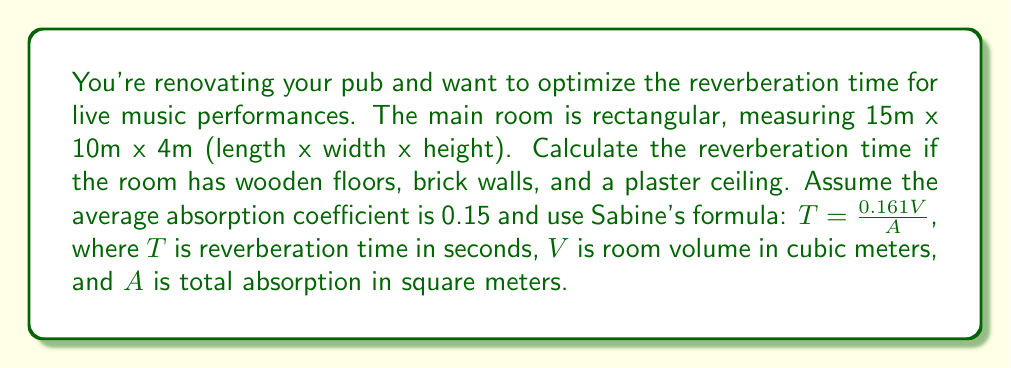Give your solution to this math problem. To solve this problem, we'll follow these steps:

1. Calculate the room volume $V$:
   $V = 15m \times 10m \times 4m = 600m^3$

2. Calculate the total surface area $S$:
   Floors and ceiling: $2 \times (15m \times 10m) = 300m^2$
   Walls: $2 \times (15m \times 4m) + 2 \times (10m \times 4m) = 200m^2$
   Total surface area: $S = 300m^2 + 200m^2 = 500m^2$

3. Calculate the total absorption $A$:
   $A = \alpha S$, where $\alpha$ is the average absorption coefficient
   $A = 0.15 \times 500m^2 = 75m^2$

4. Apply Sabine's formula:
   $$T = \frac{0.161V}{A} = \frac{0.161 \times 600m^3}{75m^2} = 1.288s$$

5. Round the result to two decimal places:
   $T \approx 1.29s$
Answer: 1.29 seconds 